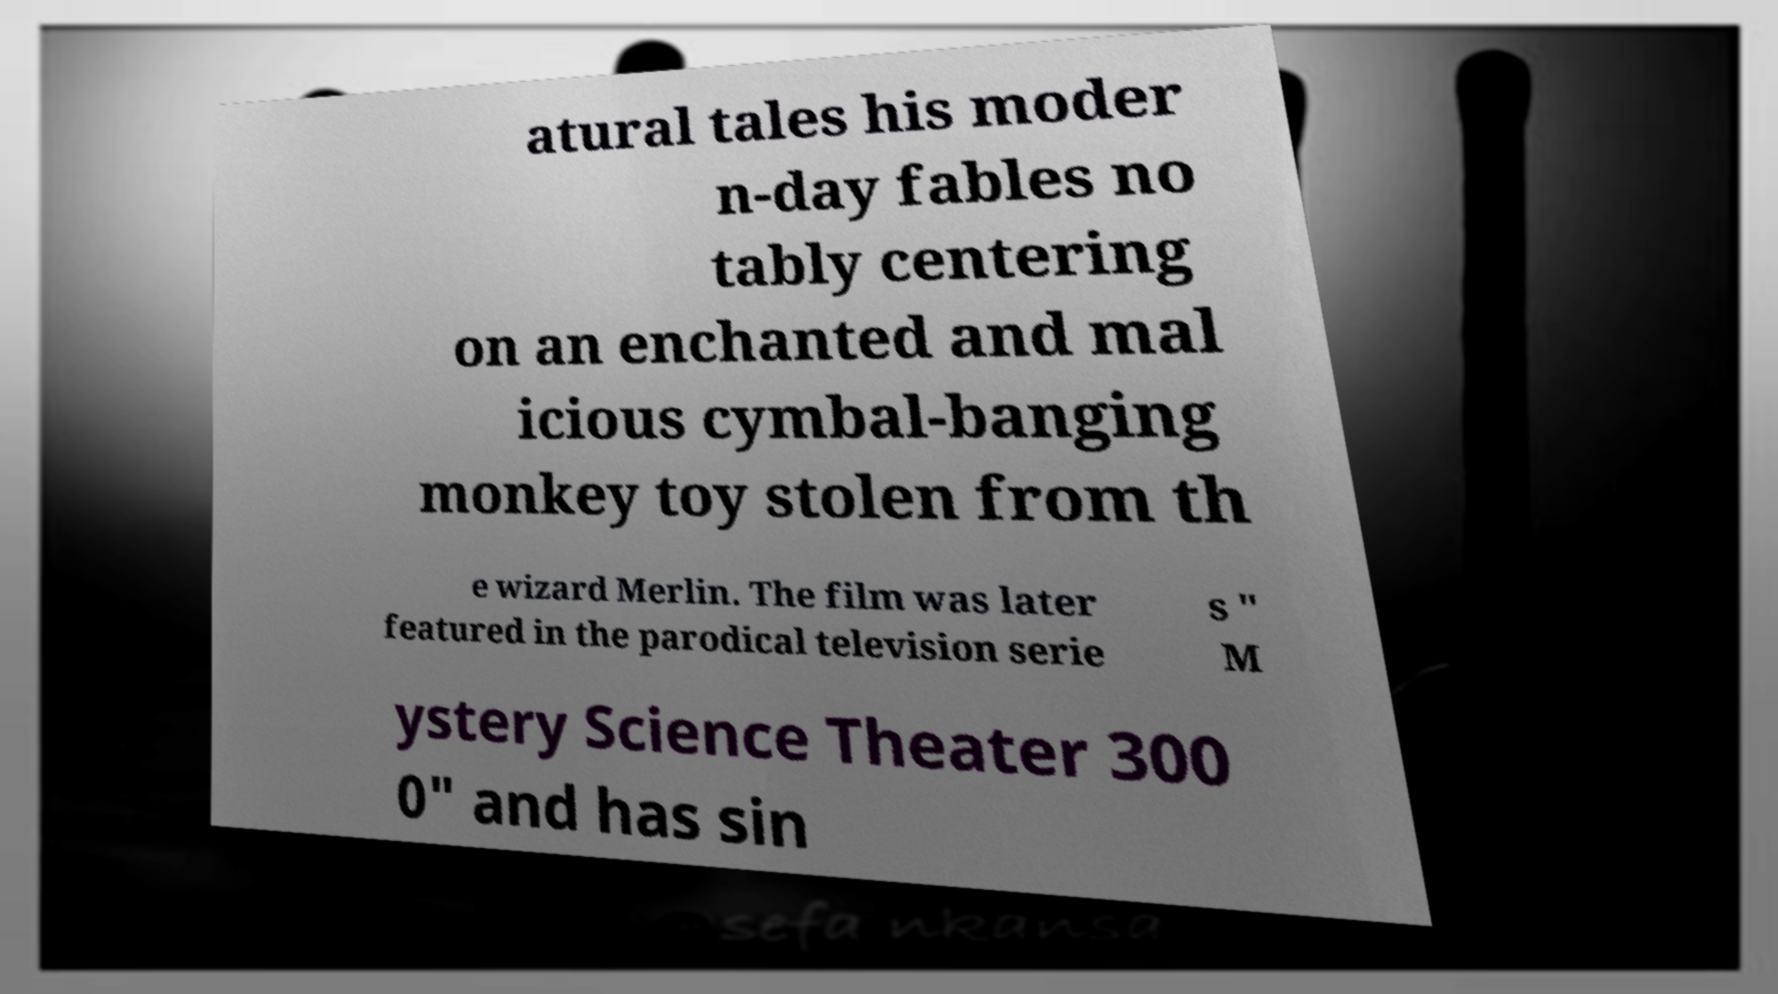I need the written content from this picture converted into text. Can you do that? atural tales his moder n-day fables no tably centering on an enchanted and mal icious cymbal-banging monkey toy stolen from th e wizard Merlin. The film was later featured in the parodical television serie s " M ystery Science Theater 300 0" and has sin 